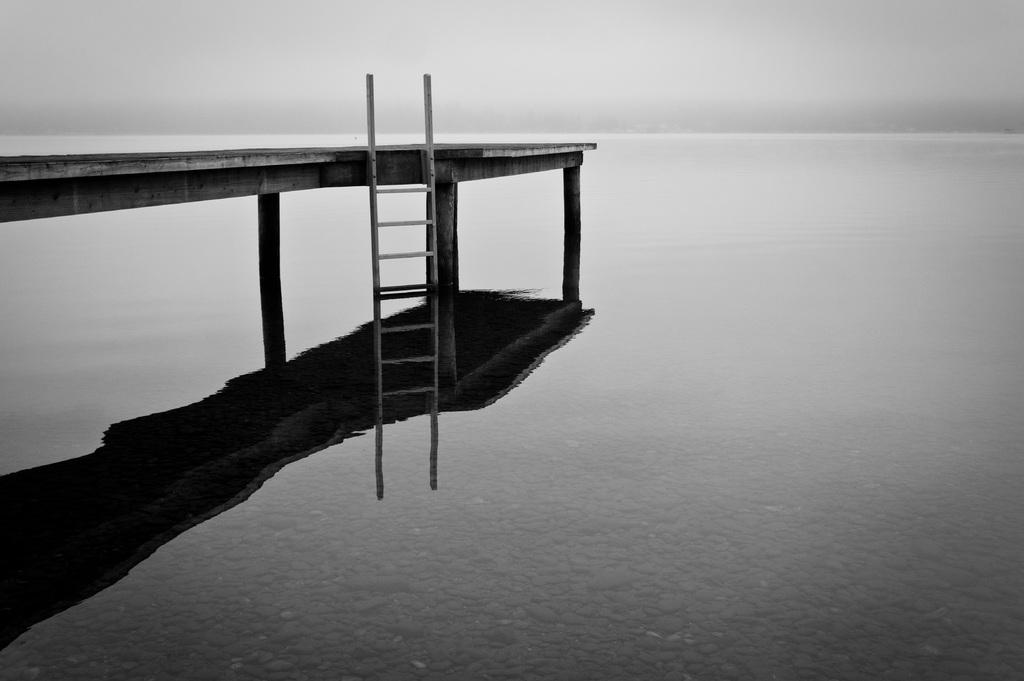What type of natural feature is present in the image? There is a sea in the image. What else can be seen in the sky in the image? There is a sky visible in the image. What is reflected on the water surface in the image? There is a reflection of a bridge on the water surface. What additional feature is attached to the bridge in the image? There is a ladder attached to the bridge. How many bodies are floating in the sea in the image? There are no bodies visible in the image; it only shows a sea, sky, reflection of a bridge, and a ladder attached to the bridge. 